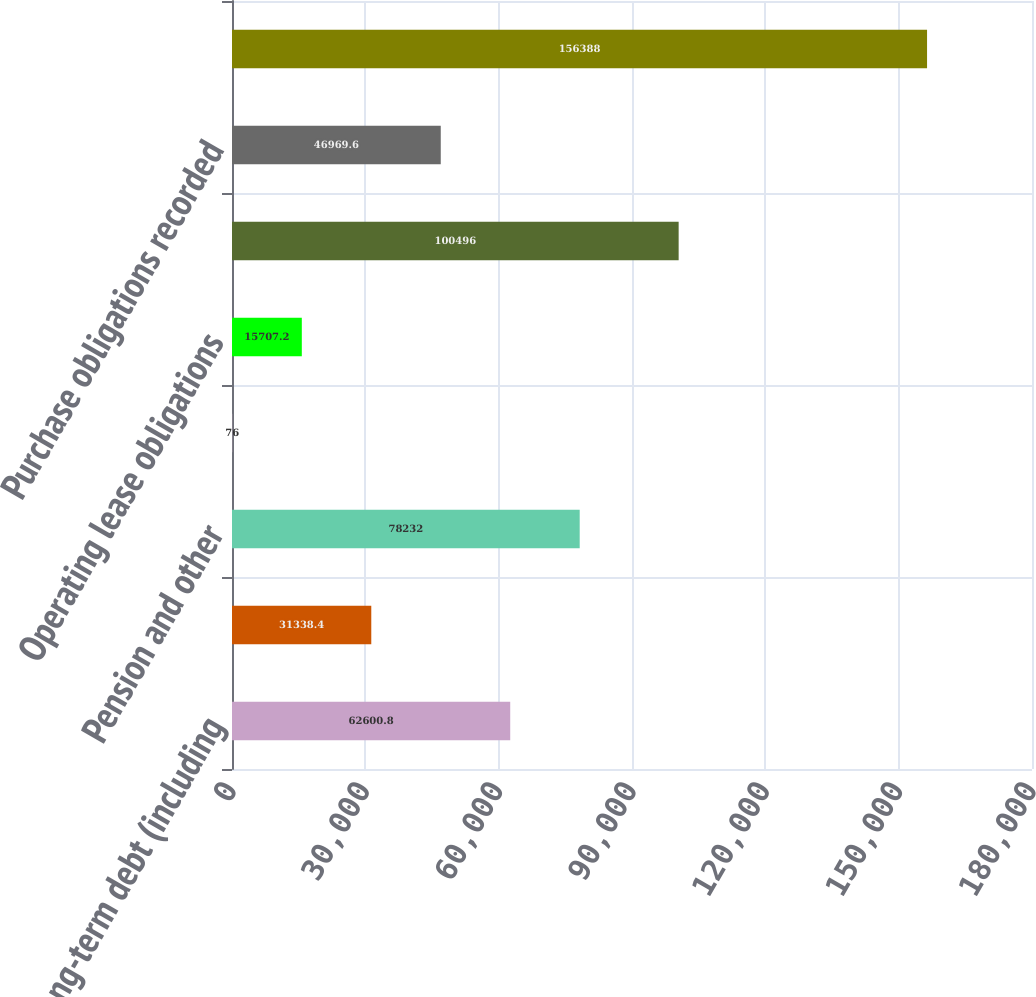<chart> <loc_0><loc_0><loc_500><loc_500><bar_chart><fcel>Long-term debt (including<fcel>Interest on debt<fcel>Pension and other<fcel>Capital lease obligations<fcel>Operating lease obligations<fcel>Purchase obligations not<fcel>Purchase obligations recorded<fcel>Total contractual obligations<nl><fcel>62600.8<fcel>31338.4<fcel>78232<fcel>76<fcel>15707.2<fcel>100496<fcel>46969.6<fcel>156388<nl></chart> 